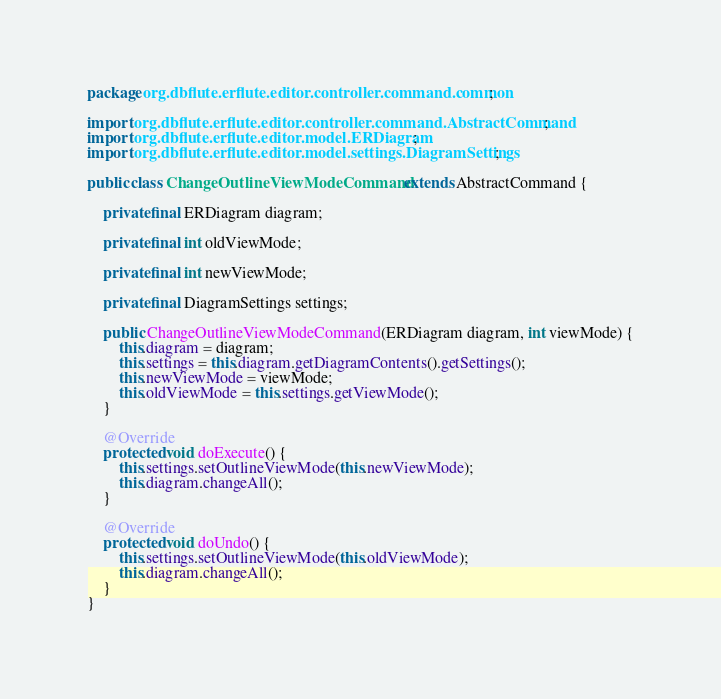<code> <loc_0><loc_0><loc_500><loc_500><_Java_>package org.dbflute.erflute.editor.controller.command.common;

import org.dbflute.erflute.editor.controller.command.AbstractCommand;
import org.dbflute.erflute.editor.model.ERDiagram;
import org.dbflute.erflute.editor.model.settings.DiagramSettings;

public class ChangeOutlineViewModeCommand extends AbstractCommand {

    private final ERDiagram diagram;

    private final int oldViewMode;

    private final int newViewMode;

    private final DiagramSettings settings;

    public ChangeOutlineViewModeCommand(ERDiagram diagram, int viewMode) {
        this.diagram = diagram;
        this.settings = this.diagram.getDiagramContents().getSettings();
        this.newViewMode = viewMode;
        this.oldViewMode = this.settings.getViewMode();
    }

    @Override
    protected void doExecute() {
        this.settings.setOutlineViewMode(this.newViewMode);
        this.diagram.changeAll();
    }

    @Override
    protected void doUndo() {
        this.settings.setOutlineViewMode(this.oldViewMode);
        this.diagram.changeAll();
    }
}
</code> 